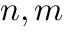<formula> <loc_0><loc_0><loc_500><loc_500>n , m</formula> 